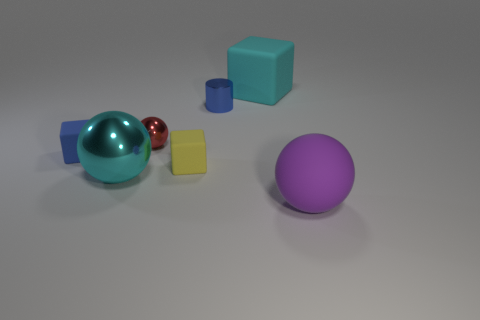Is there another large object of the same shape as the yellow object?
Give a very brief answer. Yes. Do the thing that is in front of the big cyan shiny object and the cyan object in front of the big matte cube have the same shape?
Give a very brief answer. Yes. There is a cyan cube that is the same size as the cyan metallic object; what is it made of?
Provide a succinct answer. Rubber. What number of other things are there of the same material as the cyan sphere
Ensure brevity in your answer.  2. What shape is the small shiny object right of the matte cube that is in front of the blue cube?
Your answer should be very brief. Cylinder. What number of things are either blue balls or large balls on the left side of the large purple matte sphere?
Offer a very short reply. 1. How many other objects are the same color as the rubber ball?
Make the answer very short. 0. What number of yellow objects are either tiny things or big shiny blocks?
Keep it short and to the point. 1. Is there a tiny blue shiny thing that is in front of the cube on the left side of the cyan thing left of the small cylinder?
Give a very brief answer. No. Is the color of the big matte cube the same as the large metal ball?
Offer a terse response. Yes. 